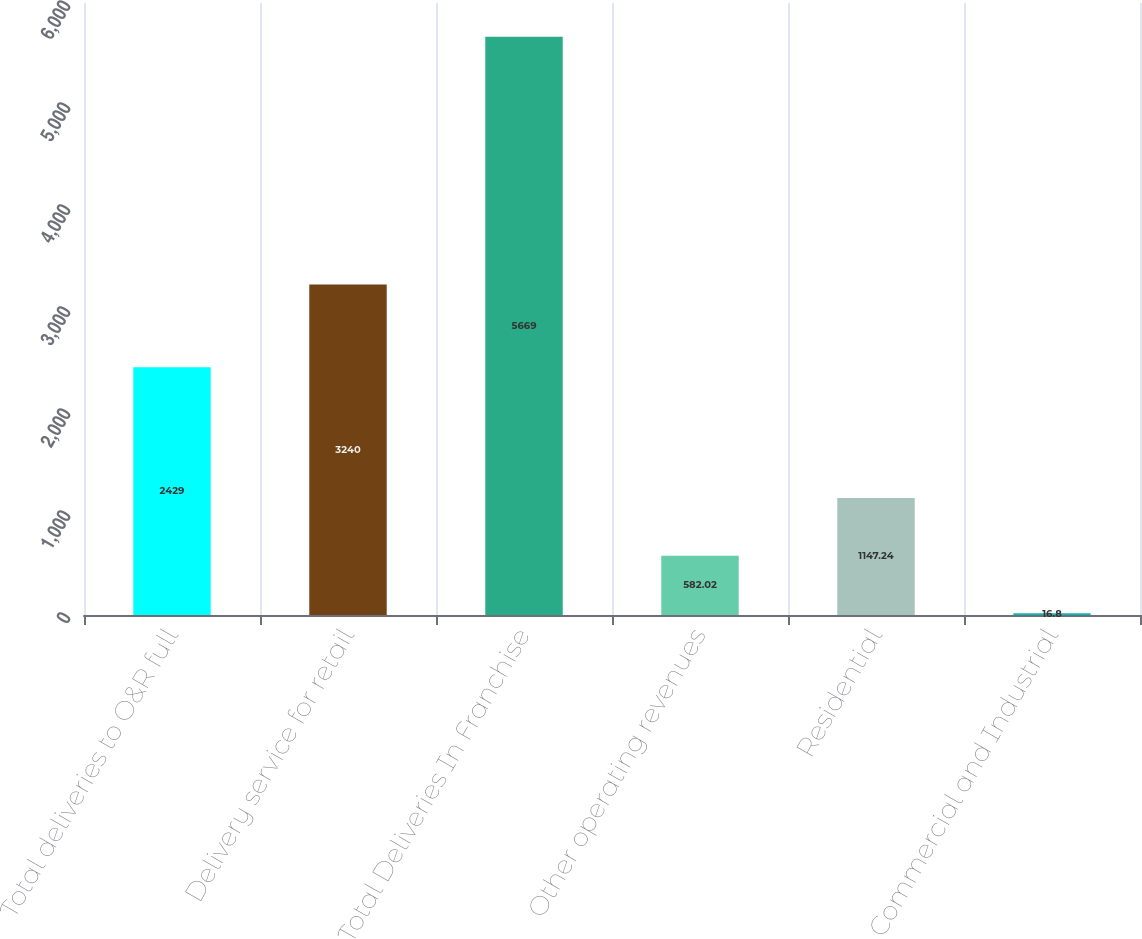<chart> <loc_0><loc_0><loc_500><loc_500><bar_chart><fcel>Total deliveries to O&R full<fcel>Delivery service for retail<fcel>Total Deliveries In Franchise<fcel>Other operating revenues<fcel>Residential<fcel>Commercial and Industrial<nl><fcel>2429<fcel>3240<fcel>5669<fcel>582.02<fcel>1147.24<fcel>16.8<nl></chart> 